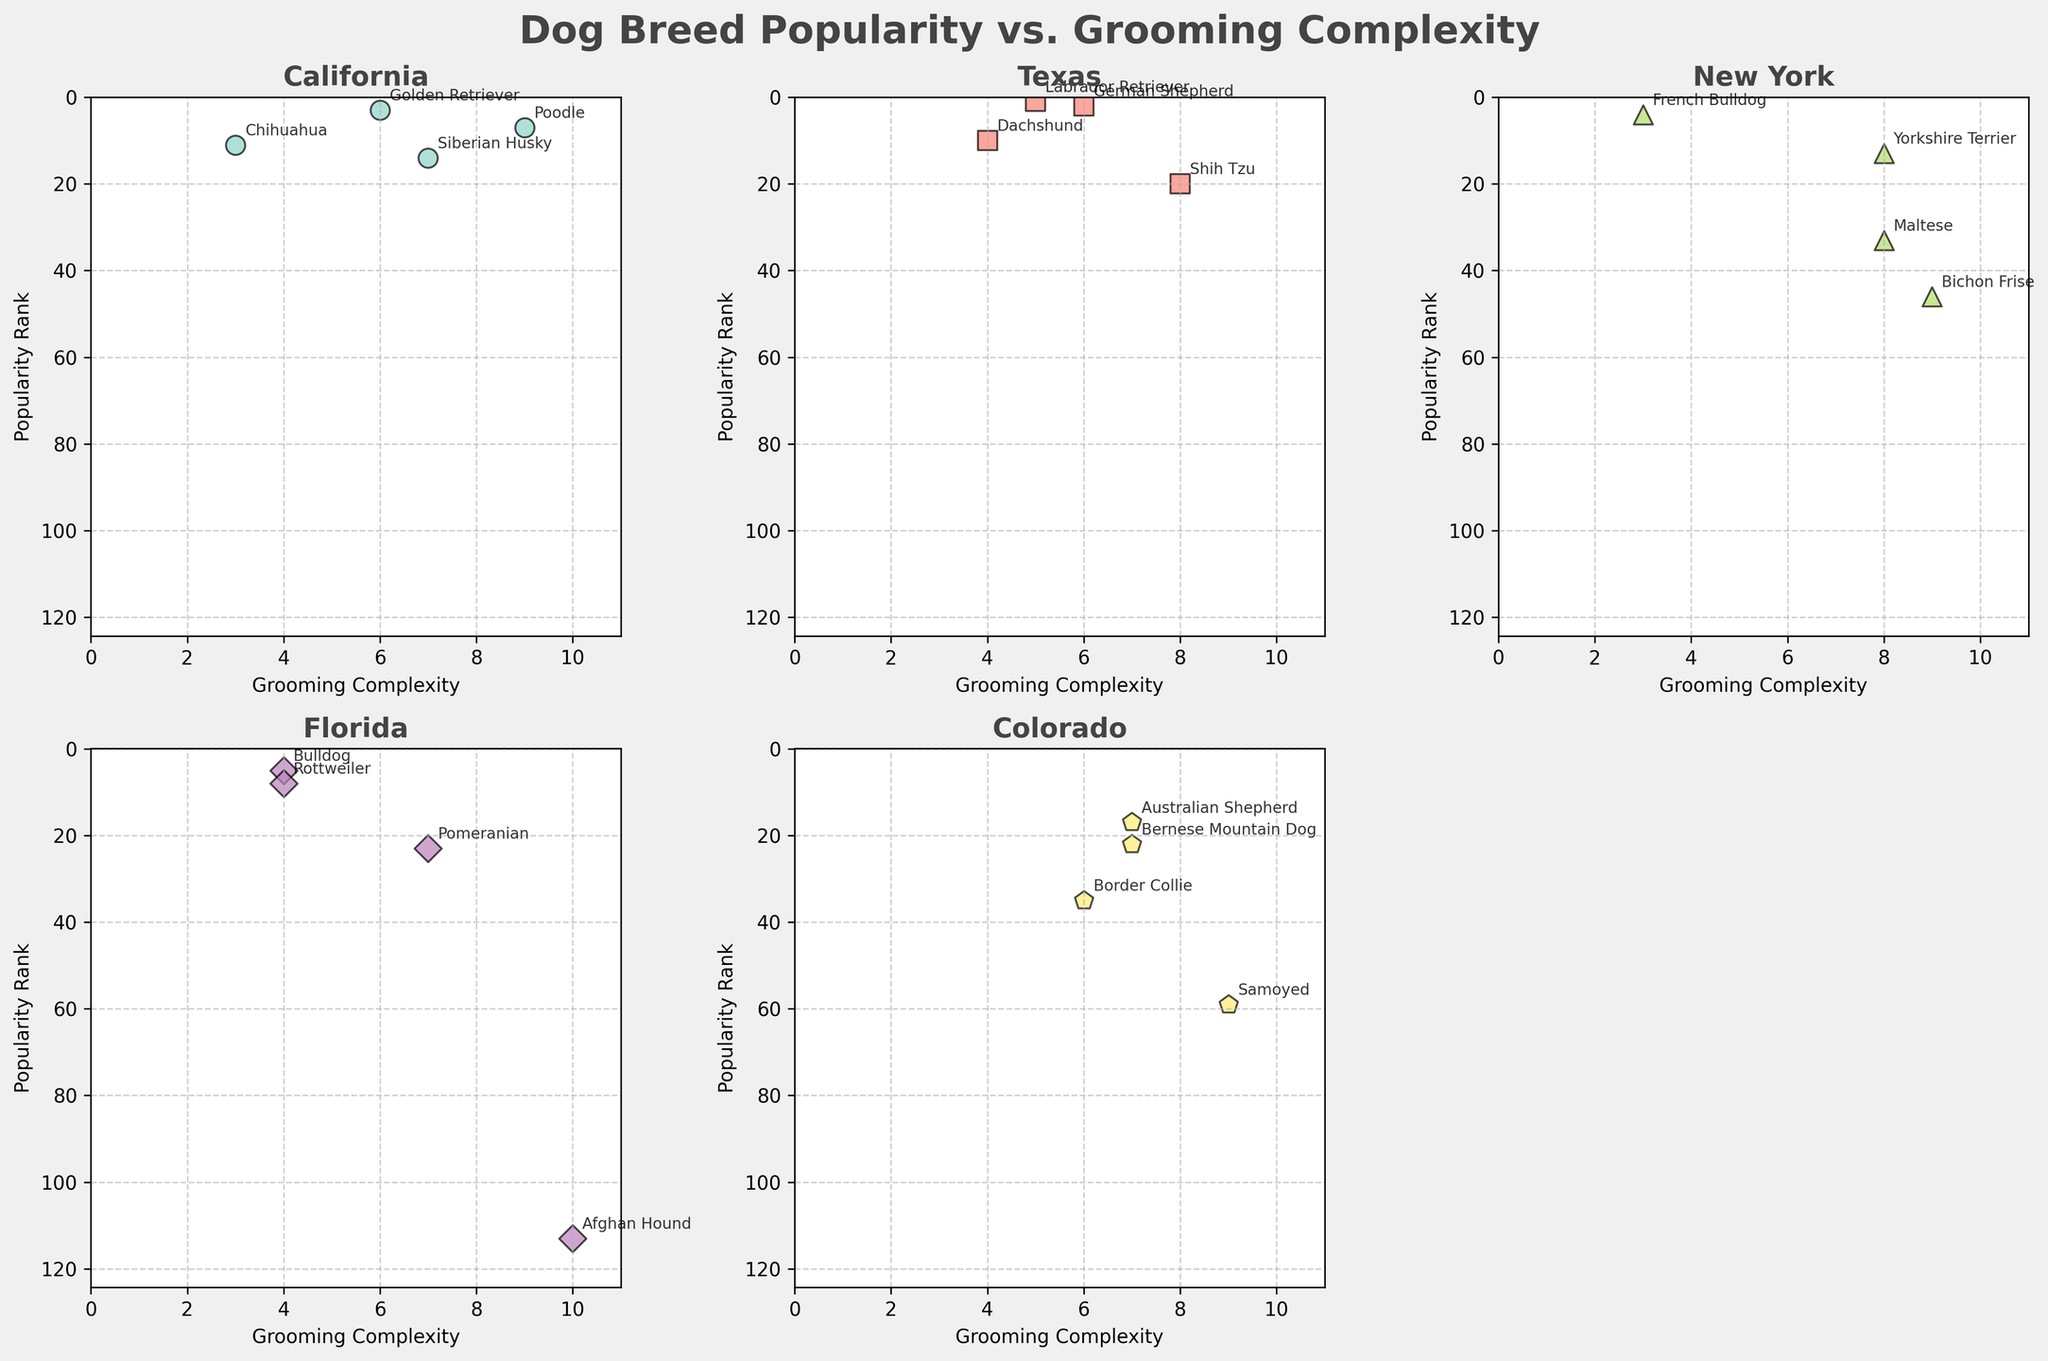What is the title of the figure? The title of the figure is displayed at the top of the overall plot, which states the main subject of the figure.
Answer: Dog Breed Popularity vs. Grooming Complexity What state has a breed with the highest grooming complexity? By looking at the subplot for each state, the breed with the highest grooming complexity score (10) is from Florida.
Answer: Florida Which breed in New York has the lowest grooming complexity? In the New York subplot, the French Bulldog has the lowest grooming complexity score of 3.
Answer: French Bulldog How many breed data points are plotted for Texas? In the Texas subplot, we can see that there are four data points plotted. Each point represents a breed.
Answer: 4 Which state has the least popular breed overall? The least popular breed is the one with the highest popularity rank value. The subplot for Florida shows that the Afghan Hound has a rank of 113, the highest among all plotted states.
Answer: Florida What is the average grooming complexity of the breeds in California? In California, the breeds' grooming complexities are 9, 6, 3, and 7. The average is calculated as (9 + 6 + 3 + 7) / 4 = 6.25.
Answer: 6.25 Compare the popularity of German Shepherds in Texas and Siberian Huskies in California. Which one is more popular? The popularity rank of German Shepherds in Texas is 2 while Siberian Huskies in California is 14. A lower rank indicates higher popularity. Therefore, the German Shepherds in Texas are more popular.
Answer: German Shepherd Which breed in Colorado has the highest grooming complexity? The Colorado subplot shows that Samoyed has the highest grooming complexity score of 9 among the breeds plotted.
Answer: Samoyed If you combine the number of breeds plotted for New York and Florida, what is the total count? New York has 4 breeds plotted and Florida also has 4 breeds plotted. Combined total: 4 (New York) + 4 (Florida) = 8 breeds.
Answer: 8 Which breed in California has the highest popularity rank? The subplot for California shows that Chihuahua has the highest popularity rank of 11 among the breeds plotted.
Answer: Chihuahua 